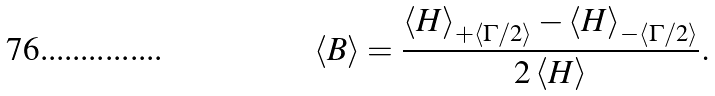Convert formula to latex. <formula><loc_0><loc_0><loc_500><loc_500>\left < B \right > = \frac { \left < H \right > _ { + \left < \Gamma / 2 \right > } - \left < H \right > _ { - \left < \Gamma / 2 \right > } } { 2 \left < H \right > } .</formula> 